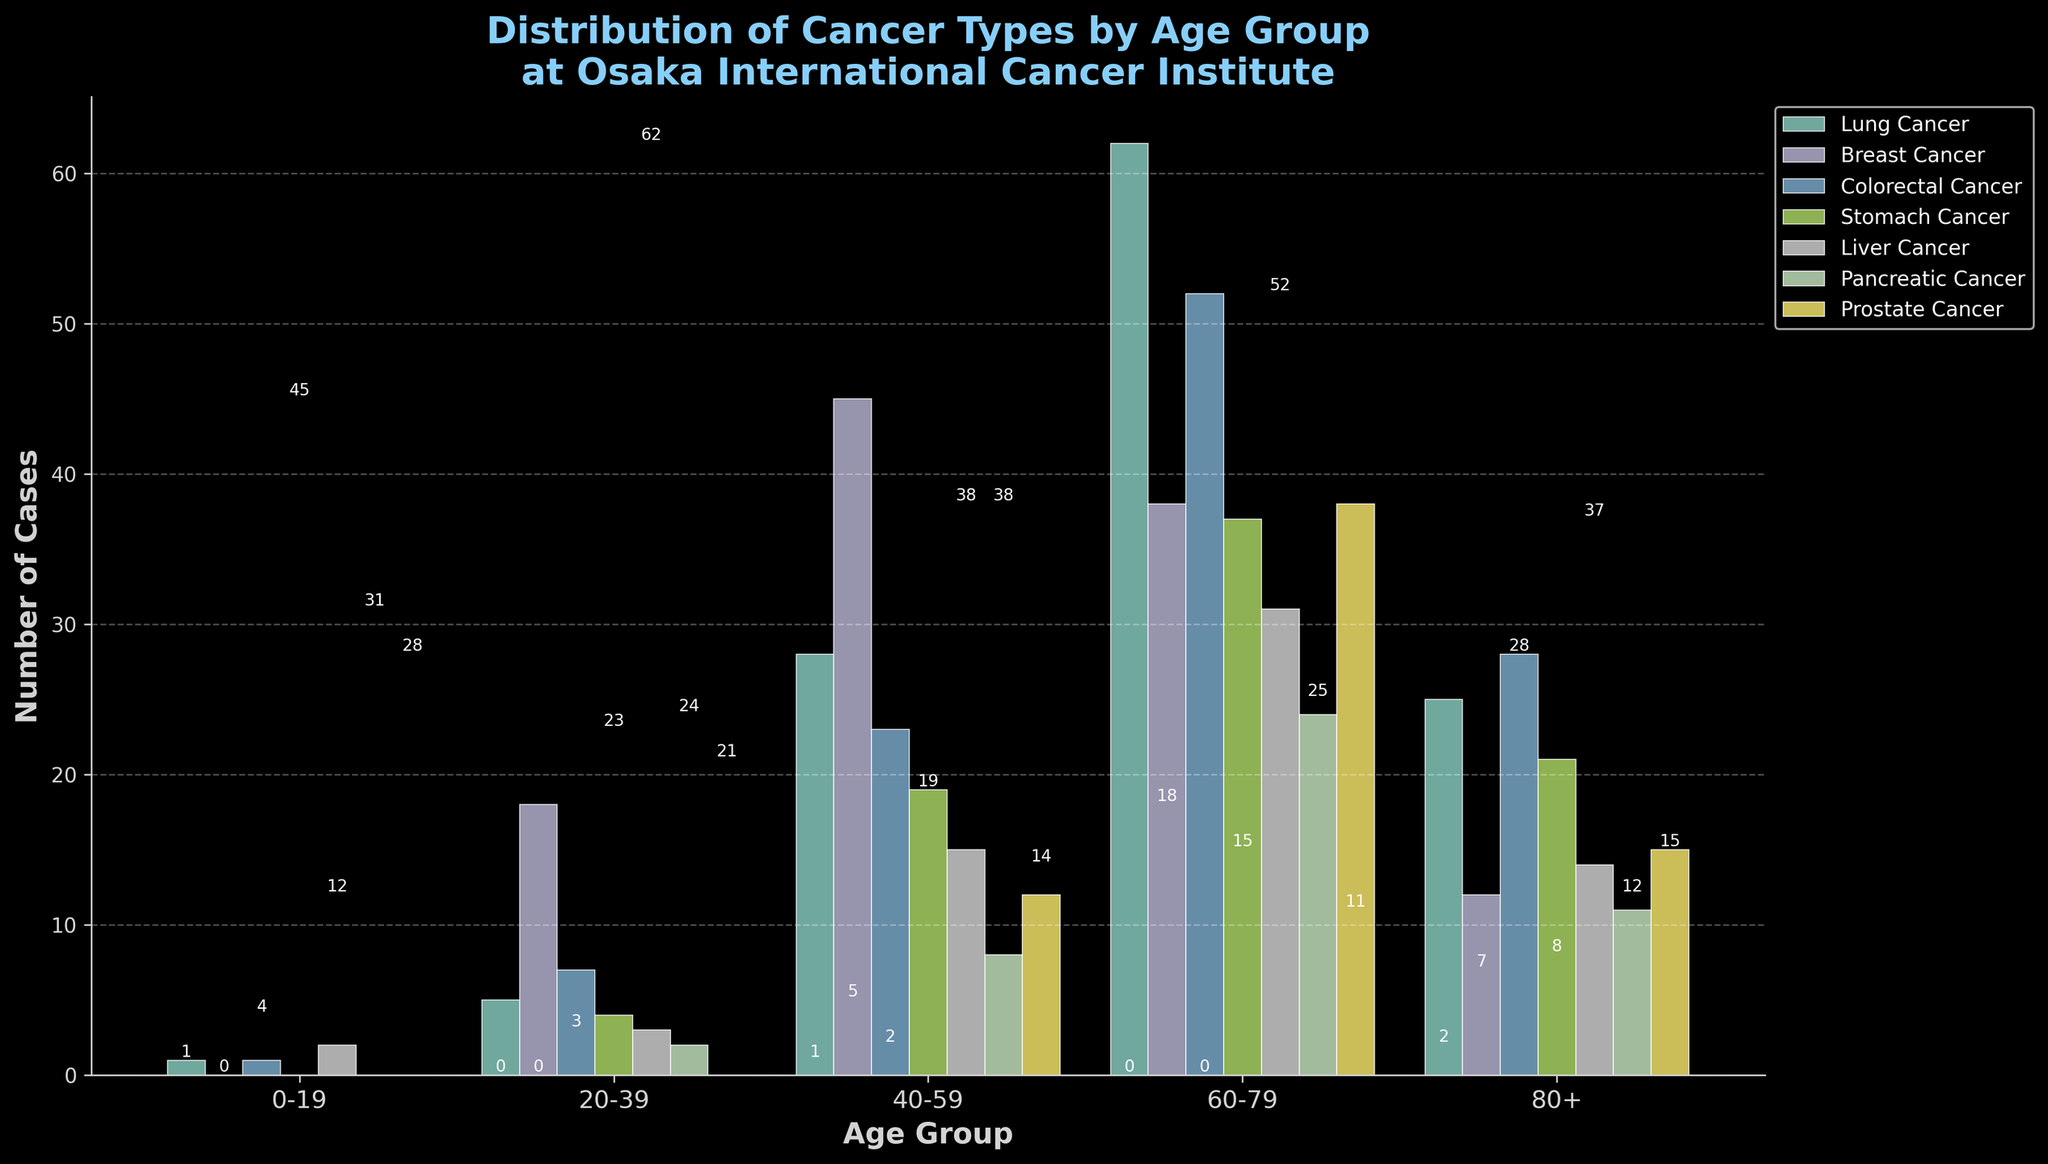Which age group has the highest number of cases for Lung Cancer? To find the highest number of Lung Cancer cases, look at the bars corresponding to Lung Cancer for each age group and identify the maximum value. The highest is 62 in the 60-79 age group.
Answer: 60-79 In the 40-59 age group, how many total cancer cases are there? Sum the counts of each cancer type for 40-59: 28 (Lung) + 45 (Breast) + 23 (Colorectal) + 19 (Stomach) + 15 (Liver) + 8 (Pancreatic) + 12 (Prostate), equaling 150.
Answer: 150 Which cancer type has the least number of cases in the 0-19 age group? Look at the values for each cancer type in the 0-19 age group and identify the smallest non-zero value, which is 0 for Breast Cancer and Pancreatic Cancer.
Answer: Breast Cancer, Pancreatic Cancer How many more cases of Breast Cancer are there in the 40-59 age group compared to the 80+ age group? Subtract the number of Breast Cancer cases in the 80+ age group from the 40-59 age group: 45 - 12 = 33.
Answer: 33 Which age group has the highest total number of cancer cases? Sum the counts for each type of cancer in all age groups and identify the group with the highest sum. The 60-79 age group has the highest total sum of 282.
Answer: 60-79 Which cancer type has the highest number of cases in the 60-79 age group? Check the counts for each type of cancer in the 60-79 age group; the highest number is Prostate Cancer with 38 cases.
Answer: Prostate Cancer How does the number of Stomach Cancer cases in the 20-39 age group compare to the 0-19 age group? Compare the counts: 4 cases for 20-39 versus 0 cases for 0-19.
Answer: 20-39 has more Is there a significant difference in Liver Cancer cases between the 40-59 and 60-79 age groups? The 40-59 age group has 15 cases, and the 60-79 age group has 31 cases, showing nearly double the amount but not a large order of magnitude difference.
Answer: Significant difference What is the average number of Prostate Cancer cases across all age groups? Sum all the Prostate Cancer cases (0 + 0 + 12 + 38 + 15 = 65), divide by the number of age groups (5): 65/5 = 13.
Answer: 13 Which cancer types see a decrease in the number of cases from the 60-79 age group to the 80+ age group? Compare the counts for each cancer type between the 60-79 and 80+ age groups: Breast Cancer (38 to 12), Stomach Cancer (37 to 21), Liver Cancer (31 to 14), and Pancreatic Cancer (24 to 11) all decrease.
Answer: Breast, Stomach, Liver, Pancreatic 